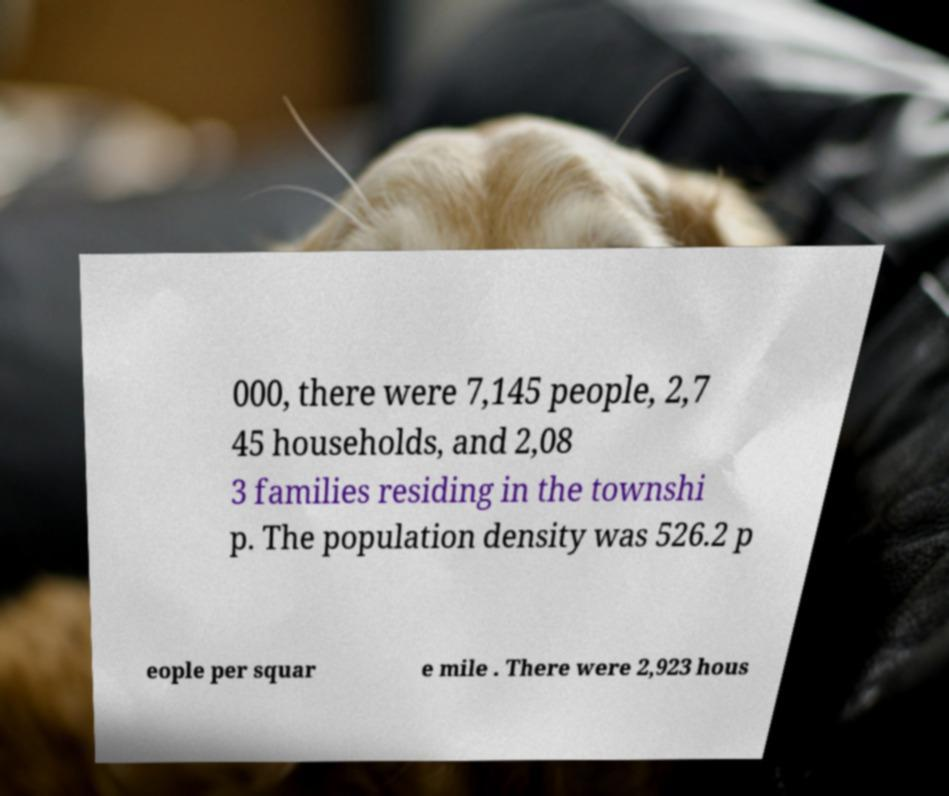Could you assist in decoding the text presented in this image and type it out clearly? 000, there were 7,145 people, 2,7 45 households, and 2,08 3 families residing in the townshi p. The population density was 526.2 p eople per squar e mile . There were 2,923 hous 